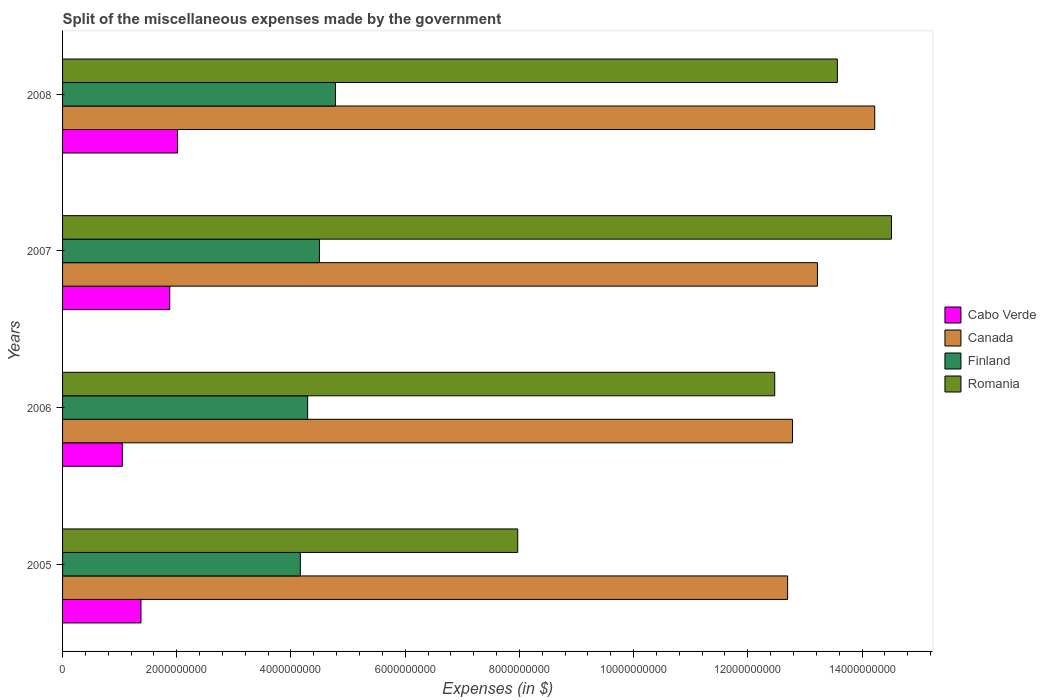Are the number of bars per tick equal to the number of legend labels?
Your answer should be very brief. Yes. How many bars are there on the 1st tick from the bottom?
Give a very brief answer. 4. In how many cases, is the number of bars for a given year not equal to the number of legend labels?
Make the answer very short. 0. What is the miscellaneous expenses made by the government in Cabo Verde in 2008?
Ensure brevity in your answer.  2.01e+09. Across all years, what is the maximum miscellaneous expenses made by the government in Finland?
Your response must be concise. 4.78e+09. Across all years, what is the minimum miscellaneous expenses made by the government in Canada?
Give a very brief answer. 1.27e+1. In which year was the miscellaneous expenses made by the government in Canada minimum?
Provide a short and direct response. 2005. What is the total miscellaneous expenses made by the government in Cabo Verde in the graph?
Your answer should be very brief. 6.31e+09. What is the difference between the miscellaneous expenses made by the government in Finland in 2005 and that in 2007?
Ensure brevity in your answer.  -3.34e+08. What is the difference between the miscellaneous expenses made by the government in Canada in 2006 and the miscellaneous expenses made by the government in Finland in 2005?
Your answer should be very brief. 8.62e+09. What is the average miscellaneous expenses made by the government in Romania per year?
Give a very brief answer. 1.21e+1. In the year 2008, what is the difference between the miscellaneous expenses made by the government in Finland and miscellaneous expenses made by the government in Romania?
Ensure brevity in your answer.  -8.79e+09. What is the ratio of the miscellaneous expenses made by the government in Canada in 2006 to that in 2008?
Your answer should be very brief. 0.9. What is the difference between the highest and the second highest miscellaneous expenses made by the government in Canada?
Offer a terse response. 1.00e+09. What is the difference between the highest and the lowest miscellaneous expenses made by the government in Canada?
Give a very brief answer. 1.52e+09. Is the sum of the miscellaneous expenses made by the government in Cabo Verde in 2007 and 2008 greater than the maximum miscellaneous expenses made by the government in Finland across all years?
Ensure brevity in your answer.  No. What does the 1st bar from the bottom in 2005 represents?
Keep it short and to the point. Cabo Verde. How many bars are there?
Your response must be concise. 16. How many years are there in the graph?
Your response must be concise. 4. What is the difference between two consecutive major ticks on the X-axis?
Give a very brief answer. 2.00e+09. Are the values on the major ticks of X-axis written in scientific E-notation?
Your answer should be compact. No. Does the graph contain any zero values?
Your answer should be very brief. No. How many legend labels are there?
Offer a very short reply. 4. What is the title of the graph?
Offer a very short reply. Split of the miscellaneous expenses made by the government. What is the label or title of the X-axis?
Give a very brief answer. Expenses (in $). What is the Expenses (in $) in Cabo Verde in 2005?
Your answer should be very brief. 1.37e+09. What is the Expenses (in $) in Canada in 2005?
Offer a very short reply. 1.27e+1. What is the Expenses (in $) of Finland in 2005?
Make the answer very short. 4.16e+09. What is the Expenses (in $) in Romania in 2005?
Provide a short and direct response. 7.97e+09. What is the Expenses (in $) of Cabo Verde in 2006?
Make the answer very short. 1.05e+09. What is the Expenses (in $) in Canada in 2006?
Your response must be concise. 1.28e+1. What is the Expenses (in $) in Finland in 2006?
Your answer should be compact. 4.29e+09. What is the Expenses (in $) of Romania in 2006?
Your answer should be compact. 1.25e+1. What is the Expenses (in $) in Cabo Verde in 2007?
Your answer should be very brief. 1.88e+09. What is the Expenses (in $) of Canada in 2007?
Your response must be concise. 1.32e+1. What is the Expenses (in $) in Finland in 2007?
Your response must be concise. 4.50e+09. What is the Expenses (in $) of Romania in 2007?
Your response must be concise. 1.45e+1. What is the Expenses (in $) of Cabo Verde in 2008?
Keep it short and to the point. 2.01e+09. What is the Expenses (in $) of Canada in 2008?
Offer a very short reply. 1.42e+1. What is the Expenses (in $) of Finland in 2008?
Your response must be concise. 4.78e+09. What is the Expenses (in $) of Romania in 2008?
Your answer should be very brief. 1.36e+1. Across all years, what is the maximum Expenses (in $) in Cabo Verde?
Your answer should be very brief. 2.01e+09. Across all years, what is the maximum Expenses (in $) in Canada?
Provide a short and direct response. 1.42e+1. Across all years, what is the maximum Expenses (in $) in Finland?
Provide a short and direct response. 4.78e+09. Across all years, what is the maximum Expenses (in $) of Romania?
Your answer should be compact. 1.45e+1. Across all years, what is the minimum Expenses (in $) of Cabo Verde?
Your answer should be very brief. 1.05e+09. Across all years, what is the minimum Expenses (in $) of Canada?
Your answer should be very brief. 1.27e+1. Across all years, what is the minimum Expenses (in $) in Finland?
Make the answer very short. 4.16e+09. Across all years, what is the minimum Expenses (in $) in Romania?
Your answer should be very brief. 7.97e+09. What is the total Expenses (in $) of Cabo Verde in the graph?
Your response must be concise. 6.31e+09. What is the total Expenses (in $) in Canada in the graph?
Keep it short and to the point. 5.29e+1. What is the total Expenses (in $) in Finland in the graph?
Offer a very short reply. 1.77e+1. What is the total Expenses (in $) in Romania in the graph?
Give a very brief answer. 4.85e+1. What is the difference between the Expenses (in $) of Cabo Verde in 2005 and that in 2006?
Your answer should be compact. 3.26e+08. What is the difference between the Expenses (in $) of Canada in 2005 and that in 2006?
Your answer should be very brief. -8.50e+07. What is the difference between the Expenses (in $) in Finland in 2005 and that in 2006?
Your answer should be very brief. -1.28e+08. What is the difference between the Expenses (in $) in Romania in 2005 and that in 2006?
Ensure brevity in your answer.  -4.50e+09. What is the difference between the Expenses (in $) of Cabo Verde in 2005 and that in 2007?
Provide a short and direct response. -5.04e+08. What is the difference between the Expenses (in $) of Canada in 2005 and that in 2007?
Offer a terse response. -5.22e+08. What is the difference between the Expenses (in $) in Finland in 2005 and that in 2007?
Keep it short and to the point. -3.34e+08. What is the difference between the Expenses (in $) of Romania in 2005 and that in 2007?
Provide a succinct answer. -6.55e+09. What is the difference between the Expenses (in $) of Cabo Verde in 2005 and that in 2008?
Offer a very short reply. -6.40e+08. What is the difference between the Expenses (in $) of Canada in 2005 and that in 2008?
Provide a short and direct response. -1.52e+09. What is the difference between the Expenses (in $) of Finland in 2005 and that in 2008?
Provide a short and direct response. -6.14e+08. What is the difference between the Expenses (in $) of Romania in 2005 and that in 2008?
Provide a succinct answer. -5.60e+09. What is the difference between the Expenses (in $) in Cabo Verde in 2006 and that in 2007?
Offer a terse response. -8.30e+08. What is the difference between the Expenses (in $) of Canada in 2006 and that in 2007?
Provide a short and direct response. -4.37e+08. What is the difference between the Expenses (in $) of Finland in 2006 and that in 2007?
Offer a very short reply. -2.06e+08. What is the difference between the Expenses (in $) in Romania in 2006 and that in 2007?
Your answer should be very brief. -2.04e+09. What is the difference between the Expenses (in $) in Cabo Verde in 2006 and that in 2008?
Your answer should be compact. -9.66e+08. What is the difference between the Expenses (in $) of Canada in 2006 and that in 2008?
Provide a succinct answer. -1.44e+09. What is the difference between the Expenses (in $) in Finland in 2006 and that in 2008?
Offer a terse response. -4.86e+08. What is the difference between the Expenses (in $) in Romania in 2006 and that in 2008?
Your answer should be very brief. -1.10e+09. What is the difference between the Expenses (in $) in Cabo Verde in 2007 and that in 2008?
Make the answer very short. -1.36e+08. What is the difference between the Expenses (in $) of Canada in 2007 and that in 2008?
Make the answer very short. -1.00e+09. What is the difference between the Expenses (in $) of Finland in 2007 and that in 2008?
Provide a short and direct response. -2.80e+08. What is the difference between the Expenses (in $) of Romania in 2007 and that in 2008?
Provide a short and direct response. 9.48e+08. What is the difference between the Expenses (in $) of Cabo Verde in 2005 and the Expenses (in $) of Canada in 2006?
Keep it short and to the point. -1.14e+1. What is the difference between the Expenses (in $) of Cabo Verde in 2005 and the Expenses (in $) of Finland in 2006?
Ensure brevity in your answer.  -2.92e+09. What is the difference between the Expenses (in $) in Cabo Verde in 2005 and the Expenses (in $) in Romania in 2006?
Provide a short and direct response. -1.11e+1. What is the difference between the Expenses (in $) in Canada in 2005 and the Expenses (in $) in Finland in 2006?
Provide a succinct answer. 8.40e+09. What is the difference between the Expenses (in $) of Canada in 2005 and the Expenses (in $) of Romania in 2006?
Provide a short and direct response. 2.26e+08. What is the difference between the Expenses (in $) in Finland in 2005 and the Expenses (in $) in Romania in 2006?
Provide a short and direct response. -8.31e+09. What is the difference between the Expenses (in $) in Cabo Verde in 2005 and the Expenses (in $) in Canada in 2007?
Provide a succinct answer. -1.18e+1. What is the difference between the Expenses (in $) in Cabo Verde in 2005 and the Expenses (in $) in Finland in 2007?
Your answer should be compact. -3.12e+09. What is the difference between the Expenses (in $) of Cabo Verde in 2005 and the Expenses (in $) of Romania in 2007?
Ensure brevity in your answer.  -1.31e+1. What is the difference between the Expenses (in $) in Canada in 2005 and the Expenses (in $) in Finland in 2007?
Your answer should be very brief. 8.20e+09. What is the difference between the Expenses (in $) in Canada in 2005 and the Expenses (in $) in Romania in 2007?
Your answer should be compact. -1.82e+09. What is the difference between the Expenses (in $) of Finland in 2005 and the Expenses (in $) of Romania in 2007?
Your response must be concise. -1.04e+1. What is the difference between the Expenses (in $) in Cabo Verde in 2005 and the Expenses (in $) in Canada in 2008?
Keep it short and to the point. -1.28e+1. What is the difference between the Expenses (in $) in Cabo Verde in 2005 and the Expenses (in $) in Finland in 2008?
Your answer should be very brief. -3.40e+09. What is the difference between the Expenses (in $) in Cabo Verde in 2005 and the Expenses (in $) in Romania in 2008?
Offer a terse response. -1.22e+1. What is the difference between the Expenses (in $) in Canada in 2005 and the Expenses (in $) in Finland in 2008?
Give a very brief answer. 7.92e+09. What is the difference between the Expenses (in $) of Canada in 2005 and the Expenses (in $) of Romania in 2008?
Ensure brevity in your answer.  -8.71e+08. What is the difference between the Expenses (in $) of Finland in 2005 and the Expenses (in $) of Romania in 2008?
Provide a succinct answer. -9.40e+09. What is the difference between the Expenses (in $) of Cabo Verde in 2006 and the Expenses (in $) of Canada in 2007?
Your answer should be compact. -1.22e+1. What is the difference between the Expenses (in $) in Cabo Verde in 2006 and the Expenses (in $) in Finland in 2007?
Provide a succinct answer. -3.45e+09. What is the difference between the Expenses (in $) in Cabo Verde in 2006 and the Expenses (in $) in Romania in 2007?
Your answer should be compact. -1.35e+1. What is the difference between the Expenses (in $) of Canada in 2006 and the Expenses (in $) of Finland in 2007?
Your answer should be compact. 8.28e+09. What is the difference between the Expenses (in $) of Canada in 2006 and the Expenses (in $) of Romania in 2007?
Your answer should be very brief. -1.73e+09. What is the difference between the Expenses (in $) in Finland in 2006 and the Expenses (in $) in Romania in 2007?
Provide a short and direct response. -1.02e+1. What is the difference between the Expenses (in $) of Cabo Verde in 2006 and the Expenses (in $) of Canada in 2008?
Keep it short and to the point. -1.32e+1. What is the difference between the Expenses (in $) in Cabo Verde in 2006 and the Expenses (in $) in Finland in 2008?
Make the answer very short. -3.73e+09. What is the difference between the Expenses (in $) of Cabo Verde in 2006 and the Expenses (in $) of Romania in 2008?
Give a very brief answer. -1.25e+1. What is the difference between the Expenses (in $) of Canada in 2006 and the Expenses (in $) of Finland in 2008?
Provide a succinct answer. 8.00e+09. What is the difference between the Expenses (in $) in Canada in 2006 and the Expenses (in $) in Romania in 2008?
Offer a terse response. -7.86e+08. What is the difference between the Expenses (in $) in Finland in 2006 and the Expenses (in $) in Romania in 2008?
Provide a succinct answer. -9.28e+09. What is the difference between the Expenses (in $) in Cabo Verde in 2007 and the Expenses (in $) in Canada in 2008?
Your response must be concise. -1.23e+1. What is the difference between the Expenses (in $) of Cabo Verde in 2007 and the Expenses (in $) of Finland in 2008?
Provide a succinct answer. -2.90e+09. What is the difference between the Expenses (in $) in Cabo Verde in 2007 and the Expenses (in $) in Romania in 2008?
Offer a terse response. -1.17e+1. What is the difference between the Expenses (in $) in Canada in 2007 and the Expenses (in $) in Finland in 2008?
Your answer should be compact. 8.44e+09. What is the difference between the Expenses (in $) in Canada in 2007 and the Expenses (in $) in Romania in 2008?
Give a very brief answer. -3.49e+08. What is the difference between the Expenses (in $) in Finland in 2007 and the Expenses (in $) in Romania in 2008?
Your response must be concise. -9.07e+09. What is the average Expenses (in $) in Cabo Verde per year?
Give a very brief answer. 1.58e+09. What is the average Expenses (in $) of Canada per year?
Ensure brevity in your answer.  1.32e+1. What is the average Expenses (in $) of Finland per year?
Make the answer very short. 4.43e+09. What is the average Expenses (in $) in Romania per year?
Your answer should be very brief. 1.21e+1. In the year 2005, what is the difference between the Expenses (in $) of Cabo Verde and Expenses (in $) of Canada?
Your answer should be compact. -1.13e+1. In the year 2005, what is the difference between the Expenses (in $) of Cabo Verde and Expenses (in $) of Finland?
Offer a terse response. -2.79e+09. In the year 2005, what is the difference between the Expenses (in $) in Cabo Verde and Expenses (in $) in Romania?
Ensure brevity in your answer.  -6.60e+09. In the year 2005, what is the difference between the Expenses (in $) in Canada and Expenses (in $) in Finland?
Your answer should be very brief. 8.53e+09. In the year 2005, what is the difference between the Expenses (in $) in Canada and Expenses (in $) in Romania?
Offer a very short reply. 4.73e+09. In the year 2005, what is the difference between the Expenses (in $) in Finland and Expenses (in $) in Romania?
Make the answer very short. -3.81e+09. In the year 2006, what is the difference between the Expenses (in $) of Cabo Verde and Expenses (in $) of Canada?
Offer a terse response. -1.17e+1. In the year 2006, what is the difference between the Expenses (in $) of Cabo Verde and Expenses (in $) of Finland?
Give a very brief answer. -3.25e+09. In the year 2006, what is the difference between the Expenses (in $) of Cabo Verde and Expenses (in $) of Romania?
Offer a terse response. -1.14e+1. In the year 2006, what is the difference between the Expenses (in $) of Canada and Expenses (in $) of Finland?
Ensure brevity in your answer.  8.49e+09. In the year 2006, what is the difference between the Expenses (in $) of Canada and Expenses (in $) of Romania?
Your response must be concise. 3.11e+08. In the year 2006, what is the difference between the Expenses (in $) in Finland and Expenses (in $) in Romania?
Your answer should be very brief. -8.18e+09. In the year 2007, what is the difference between the Expenses (in $) of Cabo Verde and Expenses (in $) of Canada?
Offer a very short reply. -1.13e+1. In the year 2007, what is the difference between the Expenses (in $) of Cabo Verde and Expenses (in $) of Finland?
Provide a succinct answer. -2.62e+09. In the year 2007, what is the difference between the Expenses (in $) in Cabo Verde and Expenses (in $) in Romania?
Provide a succinct answer. -1.26e+1. In the year 2007, what is the difference between the Expenses (in $) in Canada and Expenses (in $) in Finland?
Your answer should be very brief. 8.72e+09. In the year 2007, what is the difference between the Expenses (in $) in Canada and Expenses (in $) in Romania?
Keep it short and to the point. -1.30e+09. In the year 2007, what is the difference between the Expenses (in $) of Finland and Expenses (in $) of Romania?
Your answer should be very brief. -1.00e+1. In the year 2008, what is the difference between the Expenses (in $) in Cabo Verde and Expenses (in $) in Canada?
Provide a succinct answer. -1.22e+1. In the year 2008, what is the difference between the Expenses (in $) of Cabo Verde and Expenses (in $) of Finland?
Give a very brief answer. -2.76e+09. In the year 2008, what is the difference between the Expenses (in $) of Cabo Verde and Expenses (in $) of Romania?
Keep it short and to the point. -1.16e+1. In the year 2008, what is the difference between the Expenses (in $) of Canada and Expenses (in $) of Finland?
Ensure brevity in your answer.  9.44e+09. In the year 2008, what is the difference between the Expenses (in $) of Canada and Expenses (in $) of Romania?
Give a very brief answer. 6.54e+08. In the year 2008, what is the difference between the Expenses (in $) in Finland and Expenses (in $) in Romania?
Provide a short and direct response. -8.79e+09. What is the ratio of the Expenses (in $) in Cabo Verde in 2005 to that in 2006?
Ensure brevity in your answer.  1.31. What is the ratio of the Expenses (in $) in Finland in 2005 to that in 2006?
Your response must be concise. 0.97. What is the ratio of the Expenses (in $) of Romania in 2005 to that in 2006?
Make the answer very short. 0.64. What is the ratio of the Expenses (in $) of Cabo Verde in 2005 to that in 2007?
Keep it short and to the point. 0.73. What is the ratio of the Expenses (in $) of Canada in 2005 to that in 2007?
Offer a very short reply. 0.96. What is the ratio of the Expenses (in $) in Finland in 2005 to that in 2007?
Provide a succinct answer. 0.93. What is the ratio of the Expenses (in $) in Romania in 2005 to that in 2007?
Offer a terse response. 0.55. What is the ratio of the Expenses (in $) in Cabo Verde in 2005 to that in 2008?
Give a very brief answer. 0.68. What is the ratio of the Expenses (in $) in Canada in 2005 to that in 2008?
Offer a terse response. 0.89. What is the ratio of the Expenses (in $) in Finland in 2005 to that in 2008?
Your answer should be very brief. 0.87. What is the ratio of the Expenses (in $) in Romania in 2005 to that in 2008?
Make the answer very short. 0.59. What is the ratio of the Expenses (in $) of Cabo Verde in 2006 to that in 2007?
Ensure brevity in your answer.  0.56. What is the ratio of the Expenses (in $) in Canada in 2006 to that in 2007?
Your answer should be compact. 0.97. What is the ratio of the Expenses (in $) of Finland in 2006 to that in 2007?
Your answer should be very brief. 0.95. What is the ratio of the Expenses (in $) of Romania in 2006 to that in 2007?
Your answer should be compact. 0.86. What is the ratio of the Expenses (in $) of Cabo Verde in 2006 to that in 2008?
Keep it short and to the point. 0.52. What is the ratio of the Expenses (in $) in Canada in 2006 to that in 2008?
Keep it short and to the point. 0.9. What is the ratio of the Expenses (in $) of Finland in 2006 to that in 2008?
Offer a very short reply. 0.9. What is the ratio of the Expenses (in $) in Romania in 2006 to that in 2008?
Keep it short and to the point. 0.92. What is the ratio of the Expenses (in $) in Cabo Verde in 2007 to that in 2008?
Make the answer very short. 0.93. What is the ratio of the Expenses (in $) of Canada in 2007 to that in 2008?
Give a very brief answer. 0.93. What is the ratio of the Expenses (in $) of Finland in 2007 to that in 2008?
Your answer should be compact. 0.94. What is the ratio of the Expenses (in $) in Romania in 2007 to that in 2008?
Keep it short and to the point. 1.07. What is the difference between the highest and the second highest Expenses (in $) in Cabo Verde?
Keep it short and to the point. 1.36e+08. What is the difference between the highest and the second highest Expenses (in $) in Canada?
Offer a very short reply. 1.00e+09. What is the difference between the highest and the second highest Expenses (in $) of Finland?
Offer a very short reply. 2.80e+08. What is the difference between the highest and the second highest Expenses (in $) in Romania?
Keep it short and to the point. 9.48e+08. What is the difference between the highest and the lowest Expenses (in $) of Cabo Verde?
Ensure brevity in your answer.  9.66e+08. What is the difference between the highest and the lowest Expenses (in $) of Canada?
Offer a terse response. 1.52e+09. What is the difference between the highest and the lowest Expenses (in $) of Finland?
Offer a terse response. 6.14e+08. What is the difference between the highest and the lowest Expenses (in $) of Romania?
Keep it short and to the point. 6.55e+09. 